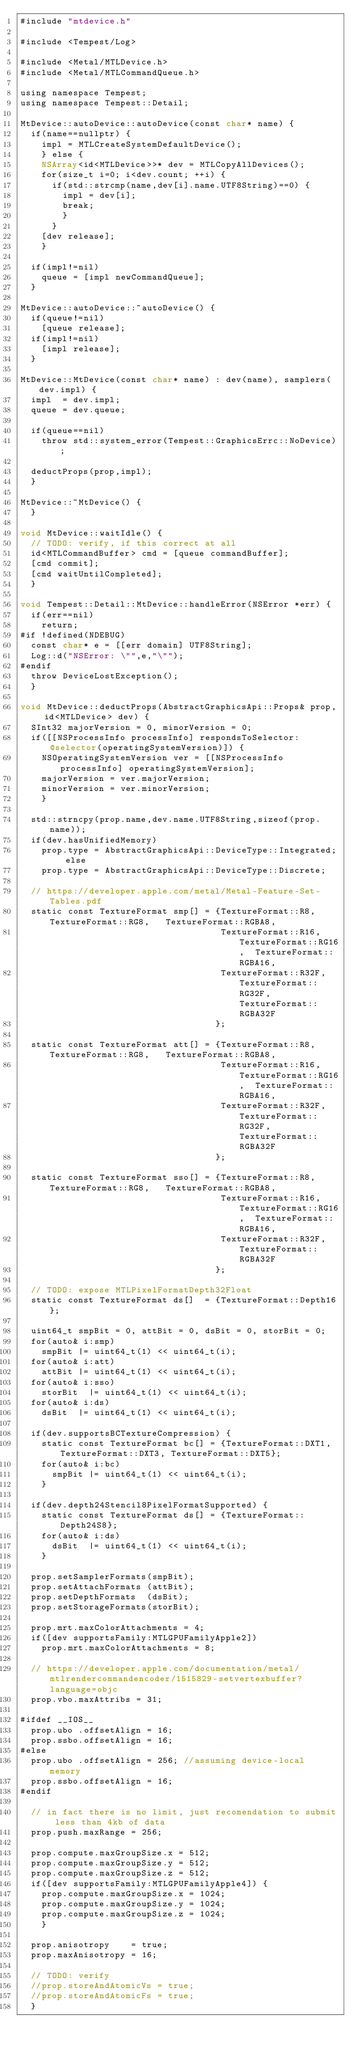Convert code to text. <code><loc_0><loc_0><loc_500><loc_500><_ObjectiveC_>#include "mtdevice.h"

#include <Tempest/Log>

#include <Metal/MTLDevice.h>
#include <Metal/MTLCommandQueue.h>

using namespace Tempest;
using namespace Tempest::Detail;

MtDevice::autoDevice::autoDevice(const char* name) {
  if(name==nullptr) {
    impl = MTLCreateSystemDefaultDevice();
    } else {
    NSArray<id<MTLDevice>>* dev = MTLCopyAllDevices();
    for(size_t i=0; i<dev.count; ++i) {
      if(std::strcmp(name,dev[i].name.UTF8String)==0) {
        impl = dev[i];
        break;
        }
      }
    [dev release];
    }

  if(impl!=nil)
    queue = [impl newCommandQueue];
  }

MtDevice::autoDevice::~autoDevice() {
  if(queue!=nil)
    [queue release];
  if(impl!=nil)
    [impl release];
  }

MtDevice::MtDevice(const char* name) : dev(name), samplers(dev.impl) {
  impl  = dev.impl;
  queue = dev.queue;

  if(queue==nil)
    throw std::system_error(Tempest::GraphicsErrc::NoDevice);

  deductProps(prop,impl);
  }

MtDevice::~MtDevice() {
  }

void MtDevice::waitIdle() {
  // TODO: verify, if this correct at all
  id<MTLCommandBuffer> cmd = [queue commandBuffer];
  [cmd commit];
  [cmd waitUntilCompleted];
  }

void Tempest::Detail::MtDevice::handleError(NSError *err) {
  if(err==nil)
    return;
#if !defined(NDEBUG)
  const char* e = [[err domain] UTF8String];
  Log::d("NSError: \"",e,"\"");
#endif
  throw DeviceLostException();
  }

void MtDevice::deductProps(AbstractGraphicsApi::Props& prop, id<MTLDevice> dev) {
  SInt32 majorVersion = 0, minorVersion = 0;
  if([[NSProcessInfo processInfo] respondsToSelector:@selector(operatingSystemVersion)]) {
    NSOperatingSystemVersion ver = [[NSProcessInfo processInfo] operatingSystemVersion];
    majorVersion = ver.majorVersion;
    minorVersion = ver.minorVersion;
    }

  std::strncpy(prop.name,dev.name.UTF8String,sizeof(prop.name));
  if(dev.hasUnifiedMemory)
    prop.type = AbstractGraphicsApi::DeviceType::Integrated; else
    prop.type = AbstractGraphicsApi::DeviceType::Discrete;

  // https://developer.apple.com/metal/Metal-Feature-Set-Tables.pdf
  static const TextureFormat smp[] = {TextureFormat::R8,   TextureFormat::RG8,   TextureFormat::RGBA8,
                                      TextureFormat::R16,  TextureFormat::RG16,  TextureFormat::RGBA16,
                                      TextureFormat::R32F, TextureFormat::RG32F, TextureFormat::RGBA32F
                                     };

  static const TextureFormat att[] = {TextureFormat::R8,   TextureFormat::RG8,   TextureFormat::RGBA8,
                                      TextureFormat::R16,  TextureFormat::RG16,  TextureFormat::RGBA16,
                                      TextureFormat::R32F, TextureFormat::RG32F, TextureFormat::RGBA32F
                                     };

  static const TextureFormat sso[] = {TextureFormat::R8,   TextureFormat::RG8,   TextureFormat::RGBA8,
                                      TextureFormat::R16,  TextureFormat::RG16,  TextureFormat::RGBA16,
                                      TextureFormat::R32F, TextureFormat::RGBA32F
                                     };

  // TODO: expose MTLPixelFormatDepth32Float
  static const TextureFormat ds[]  = {TextureFormat::Depth16};

  uint64_t smpBit = 0, attBit = 0, dsBit = 0, storBit = 0;
  for(auto& i:smp)
    smpBit |= uint64_t(1) << uint64_t(i);
  for(auto& i:att)
    attBit |= uint64_t(1) << uint64_t(i);
  for(auto& i:sso)
    storBit  |= uint64_t(1) << uint64_t(i);
  for(auto& i:ds)
    dsBit  |= uint64_t(1) << uint64_t(i);

  if(dev.supportsBCTextureCompression) {
    static const TextureFormat bc[] = {TextureFormat::DXT1, TextureFormat::DXT3, TextureFormat::DXT5};
    for(auto& i:bc)
      smpBit |= uint64_t(1) << uint64_t(i);
    }

  if(dev.depth24Stencil8PixelFormatSupported) {
    static const TextureFormat ds[] = {TextureFormat::Depth24S8};
    for(auto& i:ds)
      dsBit  |= uint64_t(1) << uint64_t(i);
    }

  prop.setSamplerFormats(smpBit);
  prop.setAttachFormats (attBit);
  prop.setDepthFormats  (dsBit);
  prop.setStorageFormats(storBit);

  prop.mrt.maxColorAttachments = 4;
  if([dev supportsFamily:MTLGPUFamilyApple2])
    prop.mrt.maxColorAttachments = 8;

  // https://developer.apple.com/documentation/metal/mtlrendercommandencoder/1515829-setvertexbuffer?language=objc
  prop.vbo.maxAttribs = 31;

#ifdef __IOS__
  prop.ubo .offsetAlign = 16;
  prop.ssbo.offsetAlign = 16;
#else
  prop.ubo .offsetAlign = 256; //assuming device-local memory
  prop.ssbo.offsetAlign = 16;
#endif

  // in fact there is no limit, just recomendation to submit less than 4kb of data
  prop.push.maxRange = 256;

  prop.compute.maxGroupSize.x = 512;
  prop.compute.maxGroupSize.y = 512;
  prop.compute.maxGroupSize.z = 512;
  if([dev supportsFamily:MTLGPUFamilyApple4]) {
    prop.compute.maxGroupSize.x = 1024;
    prop.compute.maxGroupSize.y = 1024;
    prop.compute.maxGroupSize.z = 1024;
    }

  prop.anisotropy    = true;
  prop.maxAnisotropy = 16;

  // TODO: verify
  //prop.storeAndAtomicVs = true;
  //prop.storeAndAtomicFs = true;
  }

</code> 